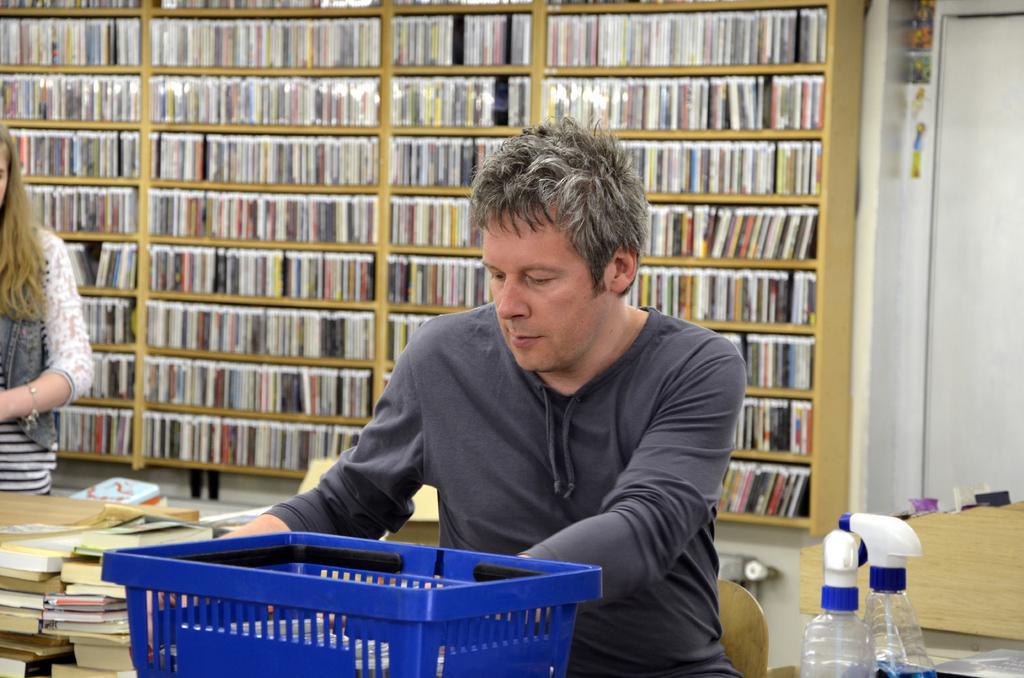Can you describe this image briefly? There is a man sitting on a chair in the center. In the background we can see a bookshelf. There is a girl on the left side. 